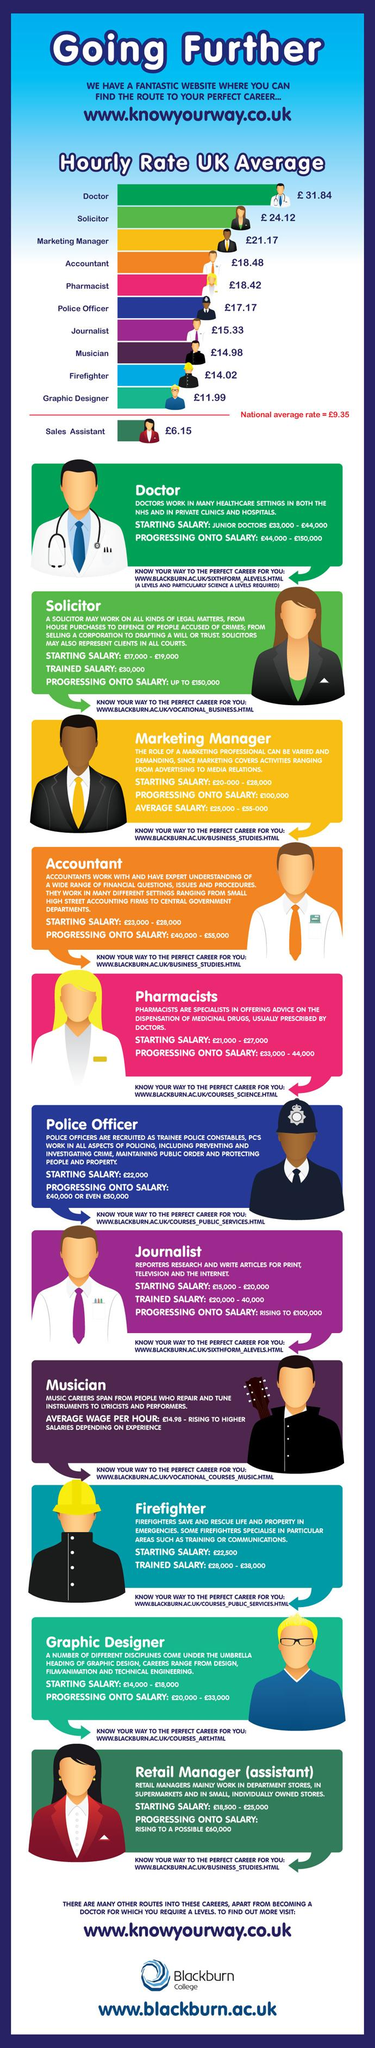Point out several critical features in this image. The maximum amount that a veteran solicitor can earn is approximately 150,000 pounds. Physicians are typically responsible for prescribing medications to their patients. The salary for a novice doctor in his career is capped at 44,000 pounds. It is commonly used to represent the hourly rate of an accountant that it is orange. According to the information provided, it can be concluded that a police officer earns more than a solicitor. 